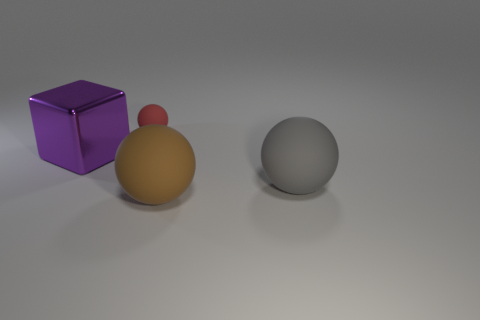Can you tell me what the purple cube represents? Without more context, it's hard to say what the purple cube represents as it can have multiple interpretations. It could symbolize structure, stability or even be part of a simplistic artistic composition. 